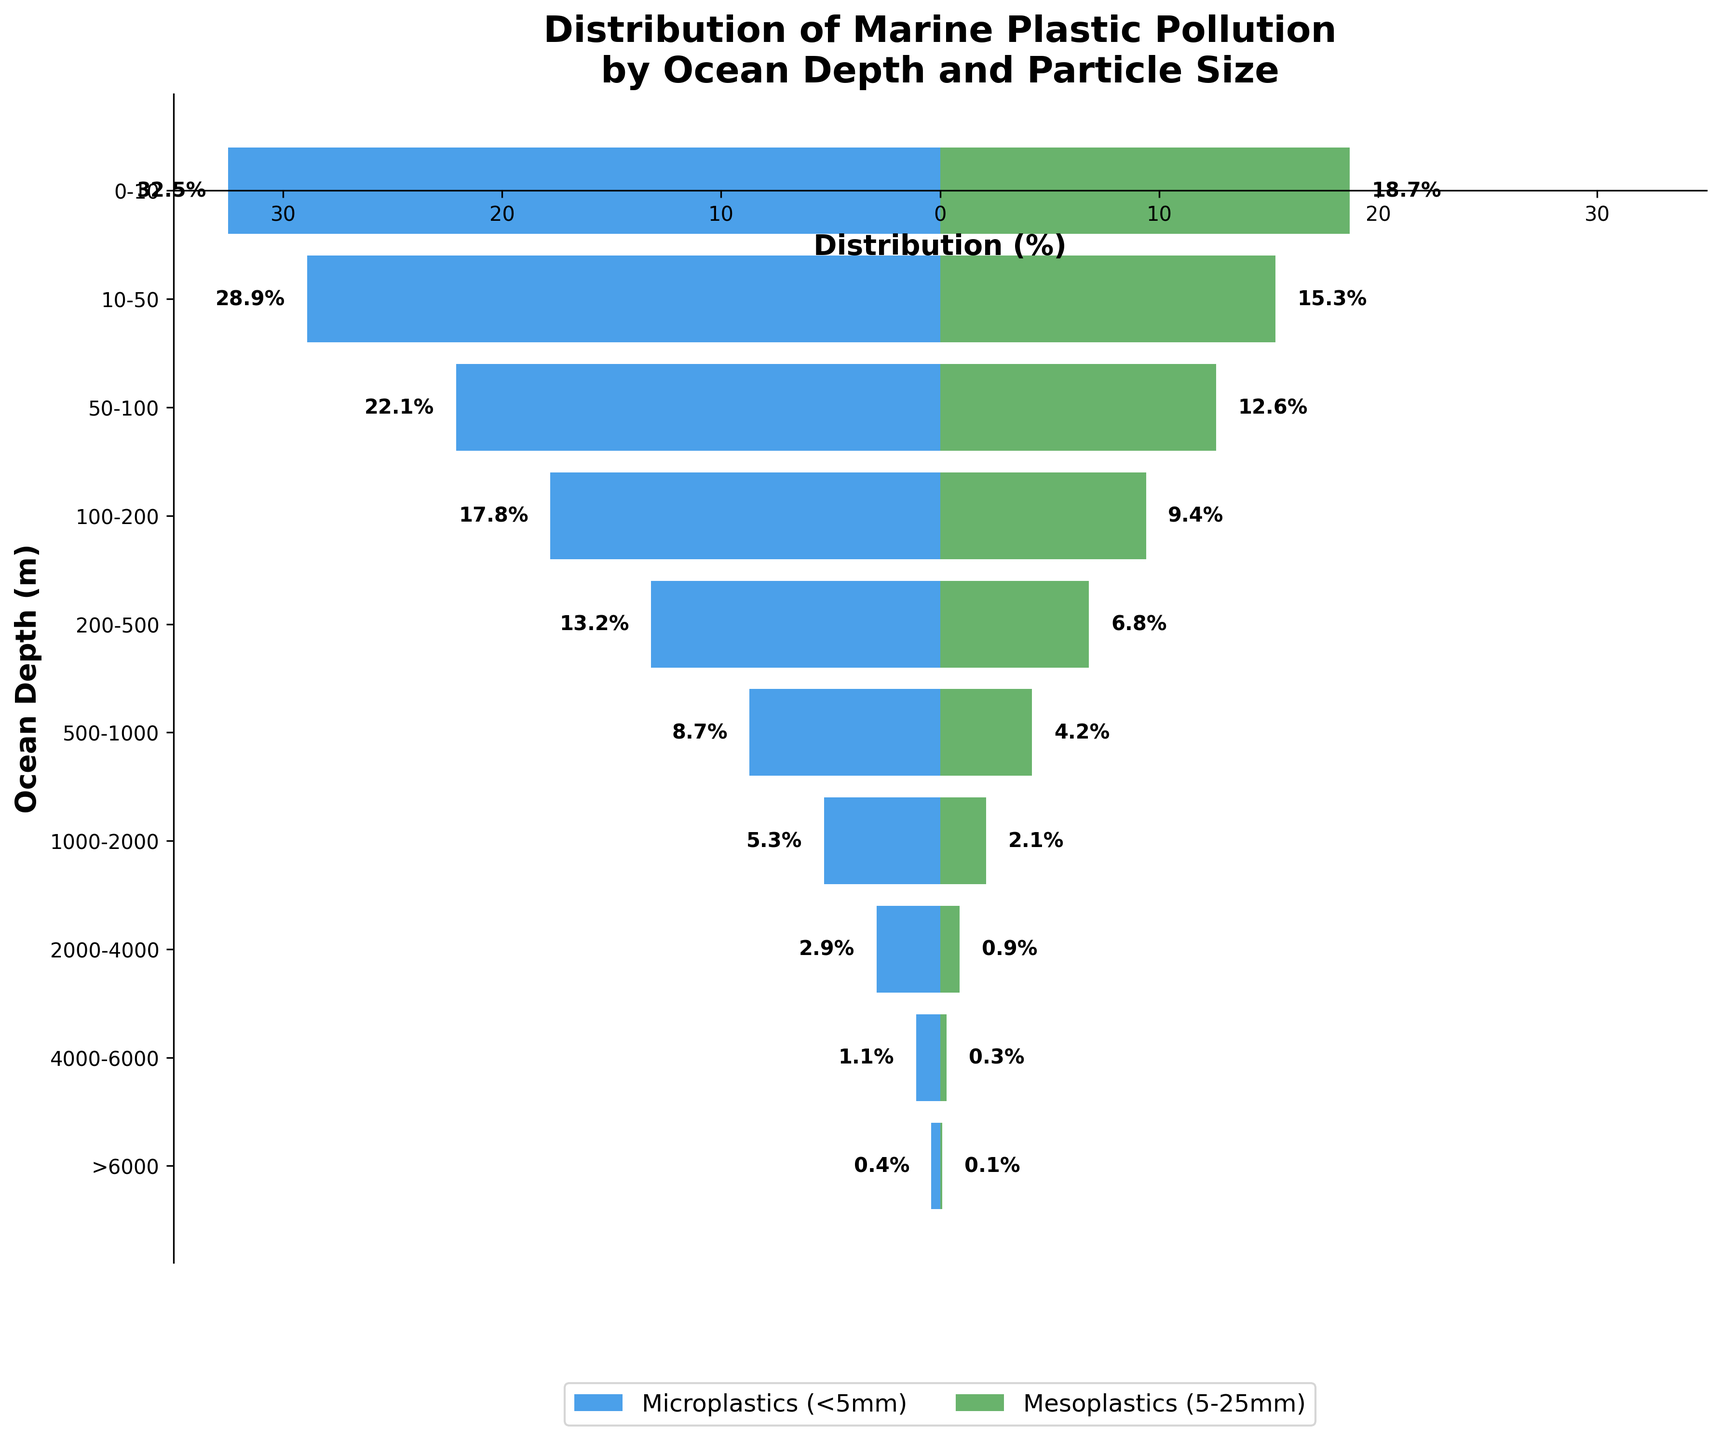What is the title of the figure? The title of the figure can be found at the top and summarizes the content. In this case, it is "Distribution of Marine Plastic Pollution by Ocean Depth and Particle Size."
Answer: Distribution of Marine Plastic Pollution by Ocean Depth and Particle Size What do the different colors of the bars represent? The color blue represents the percentage of microplastics (<5mm) at each ocean depth, while the color green represents the percentage of mesoplastics (5-25mm).
Answer: Blue for Microplastics, Green for Mesoplastics How is the ocean depth visually represented in the figure? The ocean depth is represented along the vertical axis, with labels indicating specific depth ranges in meters.
Answer: Vertical axis At which depth do we observe the maximum percentage of microplastics? By comparing the lengths of the blue bars, we see the longest is at the 0-10 meters depth, indicating the maximum percentage.
Answer: 0-10 meters How does the amount of microplastics change as depth increases from 0-10 meters to >6000 meters? The percentage of microplastics decreases steadily from 32.5% at 0-10 meters to 0.4% at >6000 meters.
Answer: It decreases Which type of plastic pollution is more prevalent in the 200-500 meters depth range? By comparing the blue and green bars at the 200-500 meters depth, we see that microplastics (blue) have a percentage of 13.2%, which is higher than 6.8% for mesoplastics (green).
Answer: Microplastics What is the combined percentage of plastic pollution (both micro and mesoplastics) at 1000-2000 meters depth? Adding the percentages of microplastics (5.3%) and mesoplastics (2.1%) at 1000-2000 meters depth gives a total of 7.4%.
Answer: 7.4% Which ocean depth range has the smallest percentage of mesoplastics? By comparing the green bars, >6000 meters depth has the shortest green bar with a percentage of 0.1%.
Answer: >6000 meters Between microplastics and mesoplastics, which particle size shows a greater variation in percentages across different depths? The blue bars (microplastics) have a much wider range from 32.5% to 0.4%, compared to the green bars (mesoplastics), which range from 18.7% to 0.1%.
Answer: Microplastics How does the distribution of mesoplastics at 2000-4000 meters compare to that at 500-1000 meters? The green bar at 2000-4000 meters shows a percentage of 0.9%, which is much lower compared to the 4.2% at 500-1000 meters depth.
Answer: It's much lower 